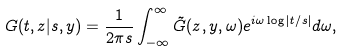Convert formula to latex. <formula><loc_0><loc_0><loc_500><loc_500>G ( t , z | s , y ) = \frac { 1 } { 2 \pi s } \int ^ { \infty } _ { - \infty } \tilde { G } ( z , y , \omega ) e ^ { i \omega \log { | t / s | } } d \omega ,</formula> 